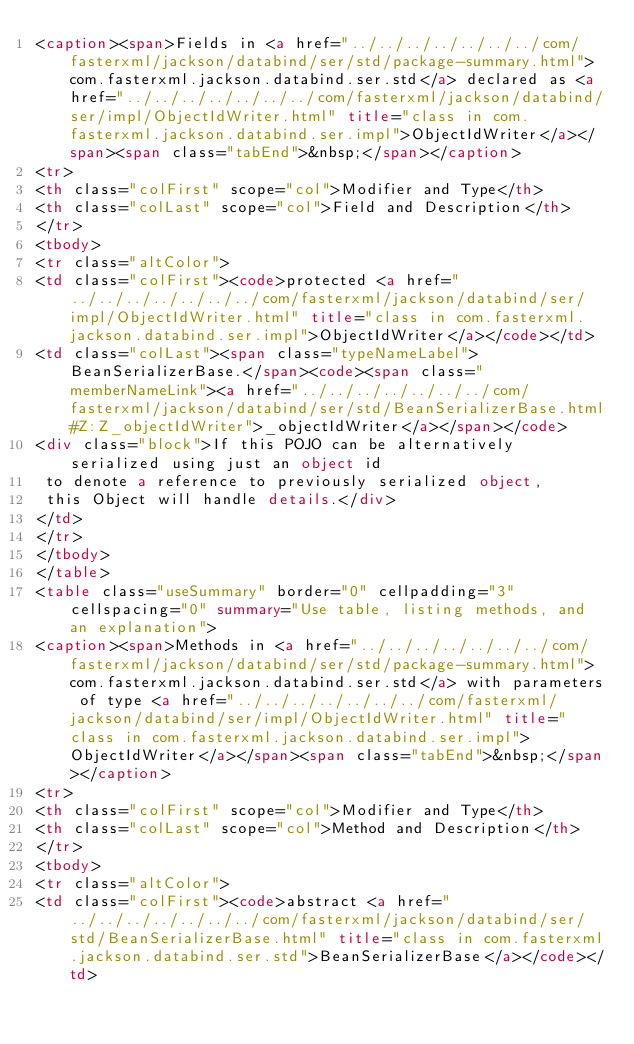<code> <loc_0><loc_0><loc_500><loc_500><_HTML_><caption><span>Fields in <a href="../../../../../../../com/fasterxml/jackson/databind/ser/std/package-summary.html">com.fasterxml.jackson.databind.ser.std</a> declared as <a href="../../../../../../../com/fasterxml/jackson/databind/ser/impl/ObjectIdWriter.html" title="class in com.fasterxml.jackson.databind.ser.impl">ObjectIdWriter</a></span><span class="tabEnd">&nbsp;</span></caption>
<tr>
<th class="colFirst" scope="col">Modifier and Type</th>
<th class="colLast" scope="col">Field and Description</th>
</tr>
<tbody>
<tr class="altColor">
<td class="colFirst"><code>protected <a href="../../../../../../../com/fasterxml/jackson/databind/ser/impl/ObjectIdWriter.html" title="class in com.fasterxml.jackson.databind.ser.impl">ObjectIdWriter</a></code></td>
<td class="colLast"><span class="typeNameLabel">BeanSerializerBase.</span><code><span class="memberNameLink"><a href="../../../../../../../com/fasterxml/jackson/databind/ser/std/BeanSerializerBase.html#Z:Z_objectIdWriter">_objectIdWriter</a></span></code>
<div class="block">If this POJO can be alternatively serialized using just an object id
 to denote a reference to previously serialized object,
 this Object will handle details.</div>
</td>
</tr>
</tbody>
</table>
<table class="useSummary" border="0" cellpadding="3" cellspacing="0" summary="Use table, listing methods, and an explanation">
<caption><span>Methods in <a href="../../../../../../../com/fasterxml/jackson/databind/ser/std/package-summary.html">com.fasterxml.jackson.databind.ser.std</a> with parameters of type <a href="../../../../../../../com/fasterxml/jackson/databind/ser/impl/ObjectIdWriter.html" title="class in com.fasterxml.jackson.databind.ser.impl">ObjectIdWriter</a></span><span class="tabEnd">&nbsp;</span></caption>
<tr>
<th class="colFirst" scope="col">Modifier and Type</th>
<th class="colLast" scope="col">Method and Description</th>
</tr>
<tbody>
<tr class="altColor">
<td class="colFirst"><code>abstract <a href="../../../../../../../com/fasterxml/jackson/databind/ser/std/BeanSerializerBase.html" title="class in com.fasterxml.jackson.databind.ser.std">BeanSerializerBase</a></code></td></code> 